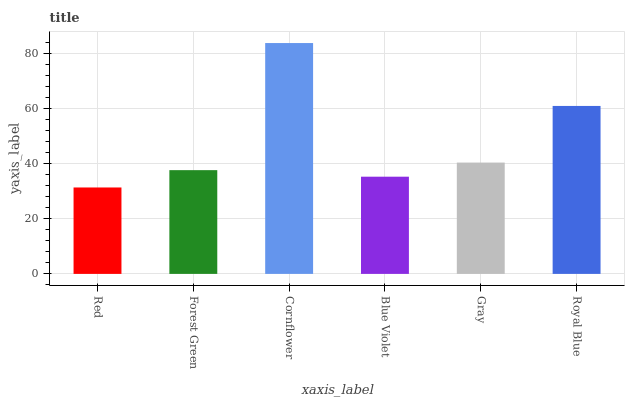Is Red the minimum?
Answer yes or no. Yes. Is Cornflower the maximum?
Answer yes or no. Yes. Is Forest Green the minimum?
Answer yes or no. No. Is Forest Green the maximum?
Answer yes or no. No. Is Forest Green greater than Red?
Answer yes or no. Yes. Is Red less than Forest Green?
Answer yes or no. Yes. Is Red greater than Forest Green?
Answer yes or no. No. Is Forest Green less than Red?
Answer yes or no. No. Is Gray the high median?
Answer yes or no. Yes. Is Forest Green the low median?
Answer yes or no. Yes. Is Royal Blue the high median?
Answer yes or no. No. Is Cornflower the low median?
Answer yes or no. No. 